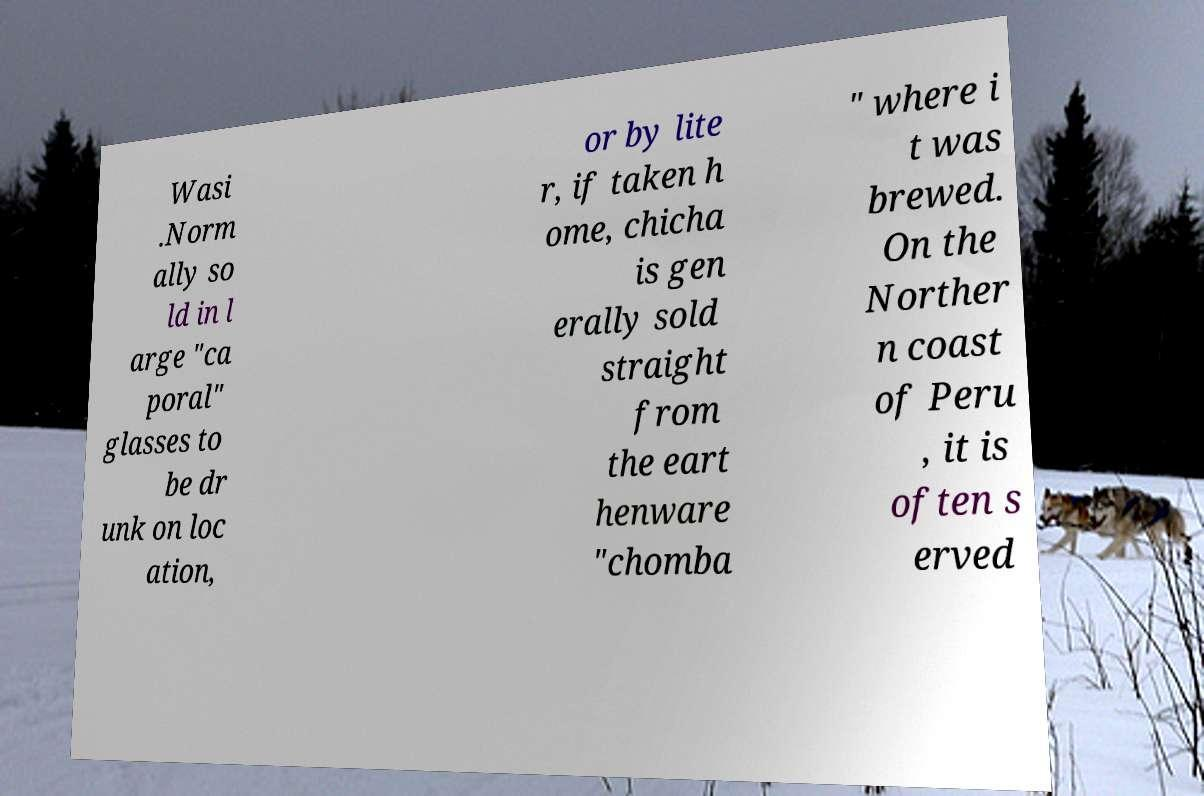I need the written content from this picture converted into text. Can you do that? Wasi .Norm ally so ld in l arge "ca poral" glasses to be dr unk on loc ation, or by lite r, if taken h ome, chicha is gen erally sold straight from the eart henware "chomba " where i t was brewed. On the Norther n coast of Peru , it is often s erved 